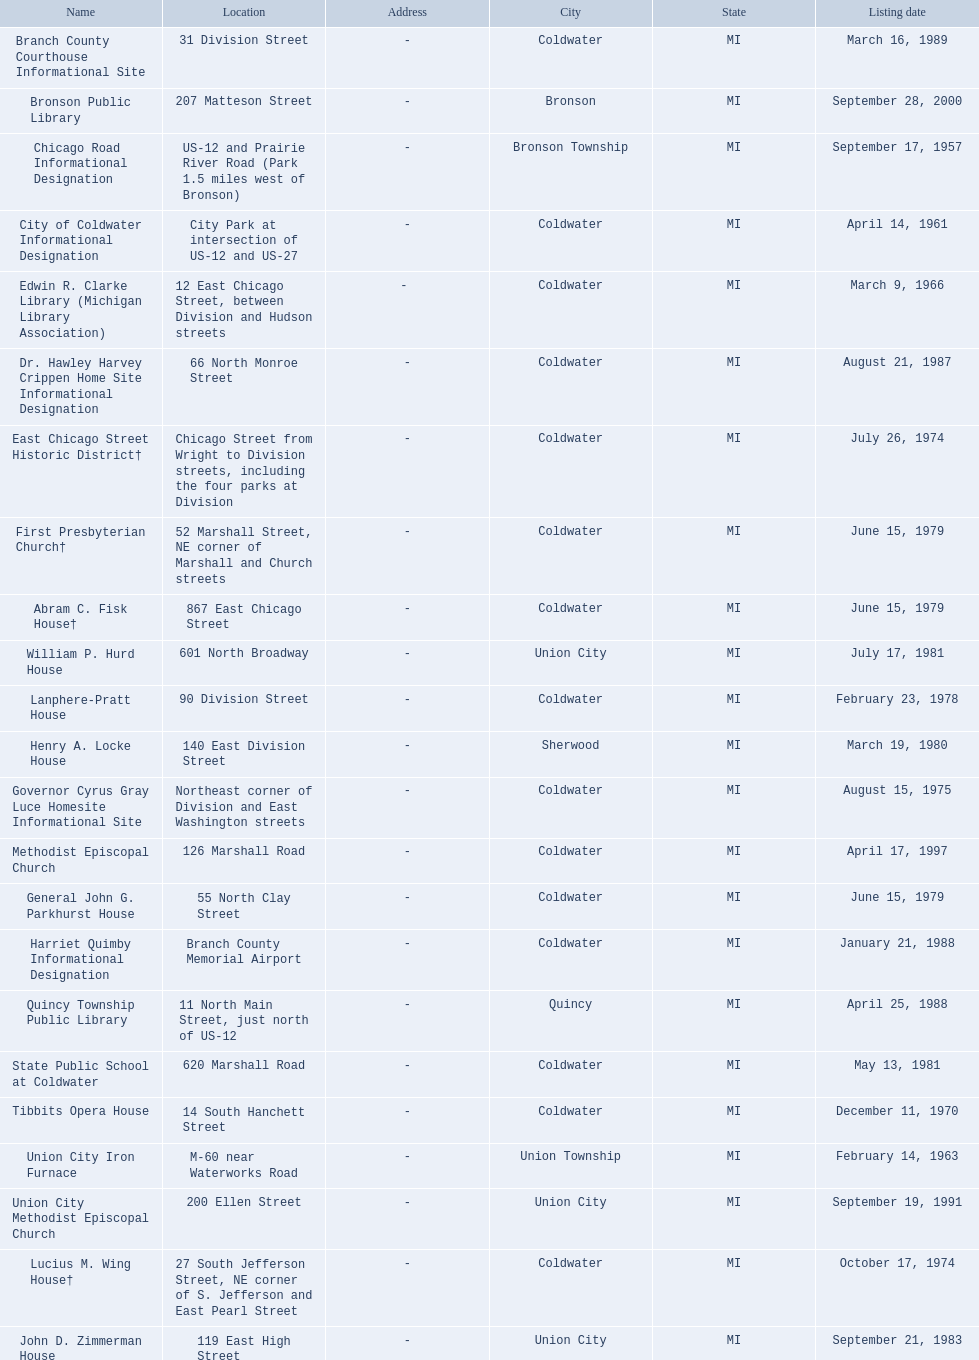Are there any listing dates that happened before 1960? September 17, 1957. What is the name of the site that was listed before 1960? Chicago Road Informational Designation. 